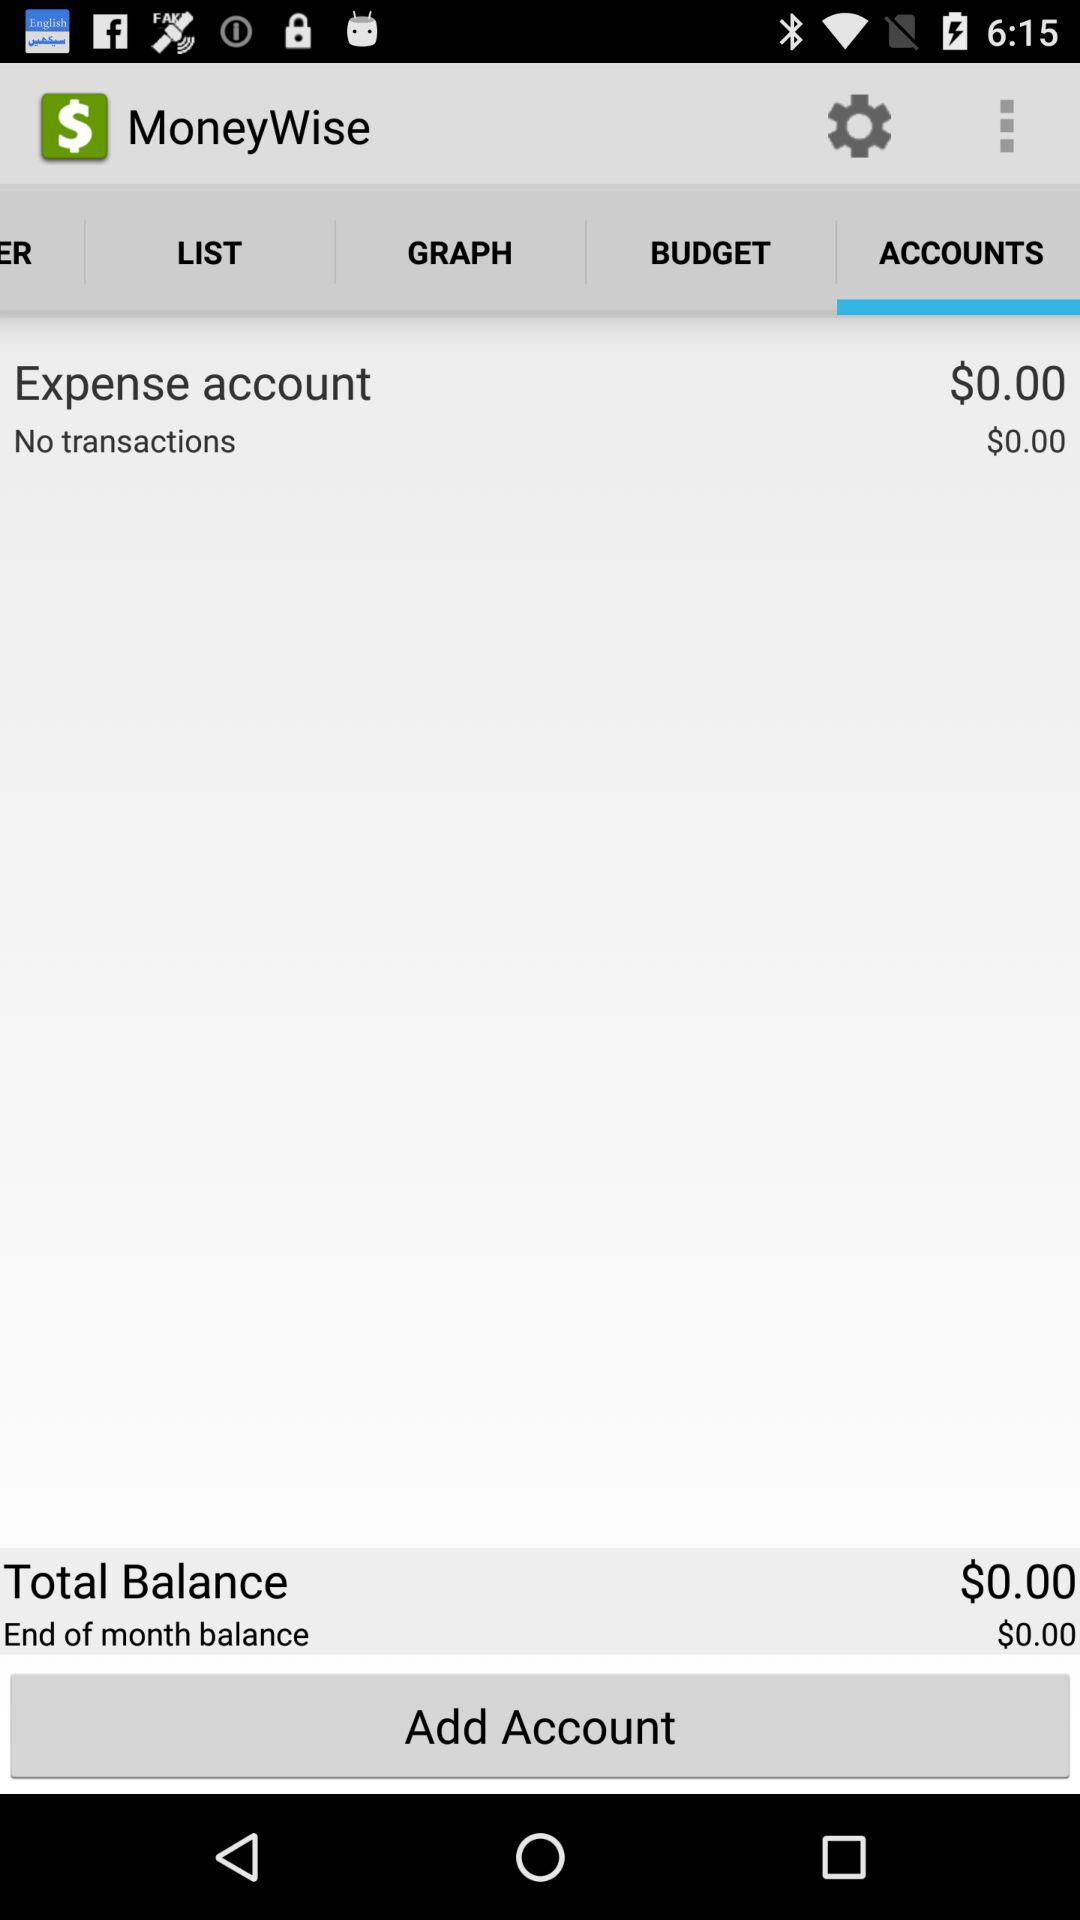What is the total balance? The total balance is $0.00. 